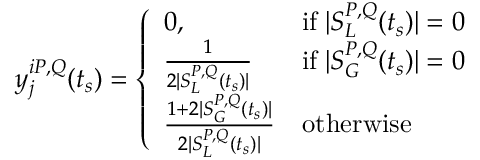Convert formula to latex. <formula><loc_0><loc_0><loc_500><loc_500>y _ { j } ^ { i P , Q } ( t _ { s } ) = \left \{ \begin{array} { l l } { 0 , } & { i f \, | S _ { L } ^ { P , Q } ( t _ { s } ) | = 0 } \\ { \frac { 1 } { 2 | S _ { L } ^ { P , Q } ( t _ { s } ) | } } & { i f \, | S _ { G } ^ { P , Q } ( t _ { s } ) | = 0 } \\ { \frac { 1 + 2 | S _ { G } ^ { P , Q } ( t _ { s } ) | } { 2 | S _ { L } ^ { P , Q } ( t _ { s } ) | } } & { o t h e r w i s e } \end{array}</formula> 